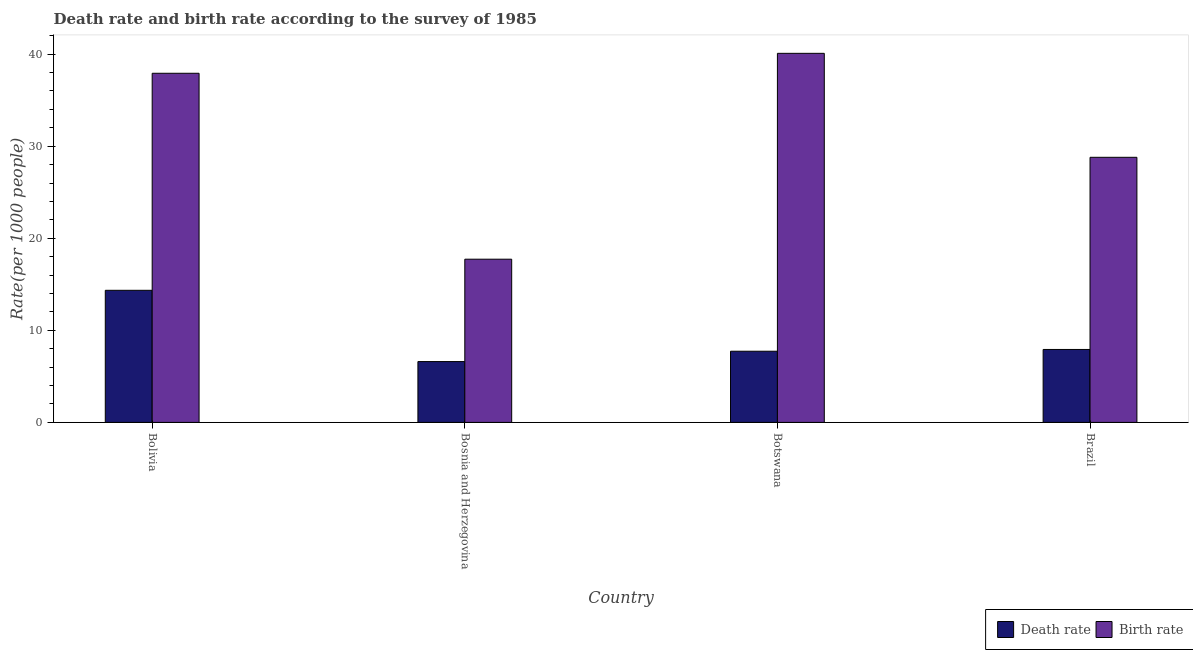How many groups of bars are there?
Provide a short and direct response. 4. Are the number of bars per tick equal to the number of legend labels?
Offer a terse response. Yes. Are the number of bars on each tick of the X-axis equal?
Ensure brevity in your answer.  Yes. What is the label of the 3rd group of bars from the left?
Your answer should be very brief. Botswana. In how many cases, is the number of bars for a given country not equal to the number of legend labels?
Provide a short and direct response. 0. What is the birth rate in Botswana?
Offer a very short reply. 40.09. Across all countries, what is the maximum birth rate?
Keep it short and to the point. 40.09. Across all countries, what is the minimum birth rate?
Keep it short and to the point. 17.73. In which country was the birth rate maximum?
Your response must be concise. Botswana. In which country was the birth rate minimum?
Offer a very short reply. Bosnia and Herzegovina. What is the total birth rate in the graph?
Your answer should be compact. 124.54. What is the difference between the birth rate in Bosnia and Herzegovina and that in Botswana?
Keep it short and to the point. -22.36. What is the difference between the birth rate in Bolivia and the death rate in Botswana?
Provide a short and direct response. 30.19. What is the average birth rate per country?
Offer a terse response. 31.13. What is the difference between the death rate and birth rate in Bolivia?
Provide a short and direct response. -23.57. What is the ratio of the death rate in Bolivia to that in Botswana?
Provide a short and direct response. 1.86. Is the difference between the death rate in Bolivia and Bosnia and Herzegovina greater than the difference between the birth rate in Bolivia and Bosnia and Herzegovina?
Offer a terse response. No. What is the difference between the highest and the second highest birth rate?
Keep it short and to the point. 2.17. What is the difference between the highest and the lowest death rate?
Make the answer very short. 7.74. In how many countries, is the death rate greater than the average death rate taken over all countries?
Ensure brevity in your answer.  1. Is the sum of the birth rate in Botswana and Brazil greater than the maximum death rate across all countries?
Your answer should be very brief. Yes. What does the 1st bar from the left in Brazil represents?
Provide a short and direct response. Death rate. What does the 1st bar from the right in Botswana represents?
Ensure brevity in your answer.  Birth rate. How many bars are there?
Your answer should be compact. 8. Are all the bars in the graph horizontal?
Your answer should be very brief. No. What is the difference between two consecutive major ticks on the Y-axis?
Provide a succinct answer. 10. Are the values on the major ticks of Y-axis written in scientific E-notation?
Provide a short and direct response. No. What is the title of the graph?
Your response must be concise. Death rate and birth rate according to the survey of 1985. What is the label or title of the Y-axis?
Your answer should be very brief. Rate(per 1000 people). What is the Rate(per 1000 people) in Death rate in Bolivia?
Provide a short and direct response. 14.35. What is the Rate(per 1000 people) of Birth rate in Bolivia?
Your answer should be compact. 37.92. What is the Rate(per 1000 people) in Death rate in Bosnia and Herzegovina?
Give a very brief answer. 6.61. What is the Rate(per 1000 people) of Birth rate in Bosnia and Herzegovina?
Provide a succinct answer. 17.73. What is the Rate(per 1000 people) in Death rate in Botswana?
Make the answer very short. 7.73. What is the Rate(per 1000 people) in Birth rate in Botswana?
Keep it short and to the point. 40.09. What is the Rate(per 1000 people) in Death rate in Brazil?
Offer a very short reply. 7.92. What is the Rate(per 1000 people) in Birth rate in Brazil?
Make the answer very short. 28.8. Across all countries, what is the maximum Rate(per 1000 people) in Death rate?
Your answer should be very brief. 14.35. Across all countries, what is the maximum Rate(per 1000 people) of Birth rate?
Ensure brevity in your answer.  40.09. Across all countries, what is the minimum Rate(per 1000 people) in Death rate?
Your answer should be very brief. 6.61. Across all countries, what is the minimum Rate(per 1000 people) in Birth rate?
Offer a terse response. 17.73. What is the total Rate(per 1000 people) of Death rate in the graph?
Your answer should be compact. 36.61. What is the total Rate(per 1000 people) in Birth rate in the graph?
Offer a terse response. 124.54. What is the difference between the Rate(per 1000 people) of Death rate in Bolivia and that in Bosnia and Herzegovina?
Keep it short and to the point. 7.74. What is the difference between the Rate(per 1000 people) of Birth rate in Bolivia and that in Bosnia and Herzegovina?
Offer a terse response. 20.2. What is the difference between the Rate(per 1000 people) of Death rate in Bolivia and that in Botswana?
Offer a very short reply. 6.62. What is the difference between the Rate(per 1000 people) of Birth rate in Bolivia and that in Botswana?
Your response must be concise. -2.17. What is the difference between the Rate(per 1000 people) of Death rate in Bolivia and that in Brazil?
Offer a very short reply. 6.43. What is the difference between the Rate(per 1000 people) in Birth rate in Bolivia and that in Brazil?
Your answer should be very brief. 9.13. What is the difference between the Rate(per 1000 people) of Death rate in Bosnia and Herzegovina and that in Botswana?
Provide a succinct answer. -1.12. What is the difference between the Rate(per 1000 people) of Birth rate in Bosnia and Herzegovina and that in Botswana?
Your response must be concise. -22.36. What is the difference between the Rate(per 1000 people) of Death rate in Bosnia and Herzegovina and that in Brazil?
Your answer should be compact. -1.32. What is the difference between the Rate(per 1000 people) of Birth rate in Bosnia and Herzegovina and that in Brazil?
Your answer should be compact. -11.07. What is the difference between the Rate(per 1000 people) of Death rate in Botswana and that in Brazil?
Your answer should be very brief. -0.19. What is the difference between the Rate(per 1000 people) of Birth rate in Botswana and that in Brazil?
Make the answer very short. 11.29. What is the difference between the Rate(per 1000 people) in Death rate in Bolivia and the Rate(per 1000 people) in Birth rate in Bosnia and Herzegovina?
Your answer should be compact. -3.38. What is the difference between the Rate(per 1000 people) in Death rate in Bolivia and the Rate(per 1000 people) in Birth rate in Botswana?
Keep it short and to the point. -25.74. What is the difference between the Rate(per 1000 people) of Death rate in Bolivia and the Rate(per 1000 people) of Birth rate in Brazil?
Provide a succinct answer. -14.45. What is the difference between the Rate(per 1000 people) of Death rate in Bosnia and Herzegovina and the Rate(per 1000 people) of Birth rate in Botswana?
Your answer should be very brief. -33.48. What is the difference between the Rate(per 1000 people) in Death rate in Bosnia and Herzegovina and the Rate(per 1000 people) in Birth rate in Brazil?
Provide a short and direct response. -22.19. What is the difference between the Rate(per 1000 people) of Death rate in Botswana and the Rate(per 1000 people) of Birth rate in Brazil?
Your response must be concise. -21.07. What is the average Rate(per 1000 people) of Death rate per country?
Offer a very short reply. 9.15. What is the average Rate(per 1000 people) in Birth rate per country?
Your response must be concise. 31.13. What is the difference between the Rate(per 1000 people) of Death rate and Rate(per 1000 people) of Birth rate in Bolivia?
Ensure brevity in your answer.  -23.57. What is the difference between the Rate(per 1000 people) in Death rate and Rate(per 1000 people) in Birth rate in Bosnia and Herzegovina?
Offer a very short reply. -11.12. What is the difference between the Rate(per 1000 people) in Death rate and Rate(per 1000 people) in Birth rate in Botswana?
Ensure brevity in your answer.  -32.36. What is the difference between the Rate(per 1000 people) in Death rate and Rate(per 1000 people) in Birth rate in Brazil?
Ensure brevity in your answer.  -20.87. What is the ratio of the Rate(per 1000 people) of Death rate in Bolivia to that in Bosnia and Herzegovina?
Provide a short and direct response. 2.17. What is the ratio of the Rate(per 1000 people) of Birth rate in Bolivia to that in Bosnia and Herzegovina?
Make the answer very short. 2.14. What is the ratio of the Rate(per 1000 people) in Death rate in Bolivia to that in Botswana?
Your answer should be very brief. 1.86. What is the ratio of the Rate(per 1000 people) of Birth rate in Bolivia to that in Botswana?
Ensure brevity in your answer.  0.95. What is the ratio of the Rate(per 1000 people) in Death rate in Bolivia to that in Brazil?
Make the answer very short. 1.81. What is the ratio of the Rate(per 1000 people) in Birth rate in Bolivia to that in Brazil?
Offer a very short reply. 1.32. What is the ratio of the Rate(per 1000 people) in Death rate in Bosnia and Herzegovina to that in Botswana?
Your answer should be compact. 0.85. What is the ratio of the Rate(per 1000 people) in Birth rate in Bosnia and Herzegovina to that in Botswana?
Make the answer very short. 0.44. What is the ratio of the Rate(per 1000 people) in Death rate in Bosnia and Herzegovina to that in Brazil?
Offer a terse response. 0.83. What is the ratio of the Rate(per 1000 people) of Birth rate in Bosnia and Herzegovina to that in Brazil?
Give a very brief answer. 0.62. What is the ratio of the Rate(per 1000 people) of Death rate in Botswana to that in Brazil?
Make the answer very short. 0.98. What is the ratio of the Rate(per 1000 people) of Birth rate in Botswana to that in Brazil?
Your answer should be very brief. 1.39. What is the difference between the highest and the second highest Rate(per 1000 people) of Death rate?
Your answer should be very brief. 6.43. What is the difference between the highest and the second highest Rate(per 1000 people) in Birth rate?
Ensure brevity in your answer.  2.17. What is the difference between the highest and the lowest Rate(per 1000 people) of Death rate?
Give a very brief answer. 7.74. What is the difference between the highest and the lowest Rate(per 1000 people) in Birth rate?
Give a very brief answer. 22.36. 